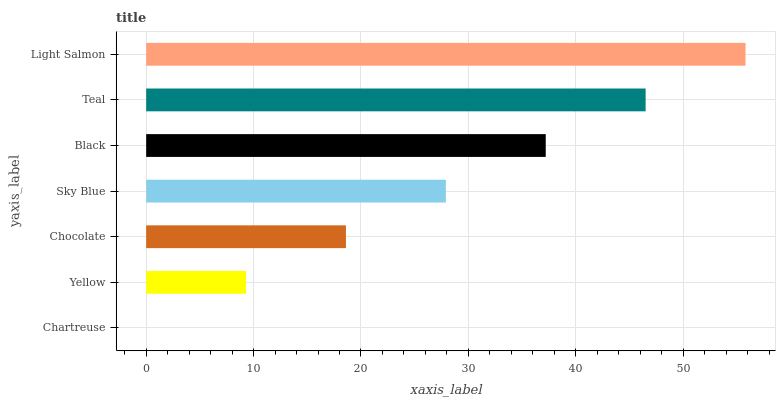Is Chartreuse the minimum?
Answer yes or no. Yes. Is Light Salmon the maximum?
Answer yes or no. Yes. Is Yellow the minimum?
Answer yes or no. No. Is Yellow the maximum?
Answer yes or no. No. Is Yellow greater than Chartreuse?
Answer yes or no. Yes. Is Chartreuse less than Yellow?
Answer yes or no. Yes. Is Chartreuse greater than Yellow?
Answer yes or no. No. Is Yellow less than Chartreuse?
Answer yes or no. No. Is Sky Blue the high median?
Answer yes or no. Yes. Is Sky Blue the low median?
Answer yes or no. Yes. Is Chocolate the high median?
Answer yes or no. No. Is Chartreuse the low median?
Answer yes or no. No. 